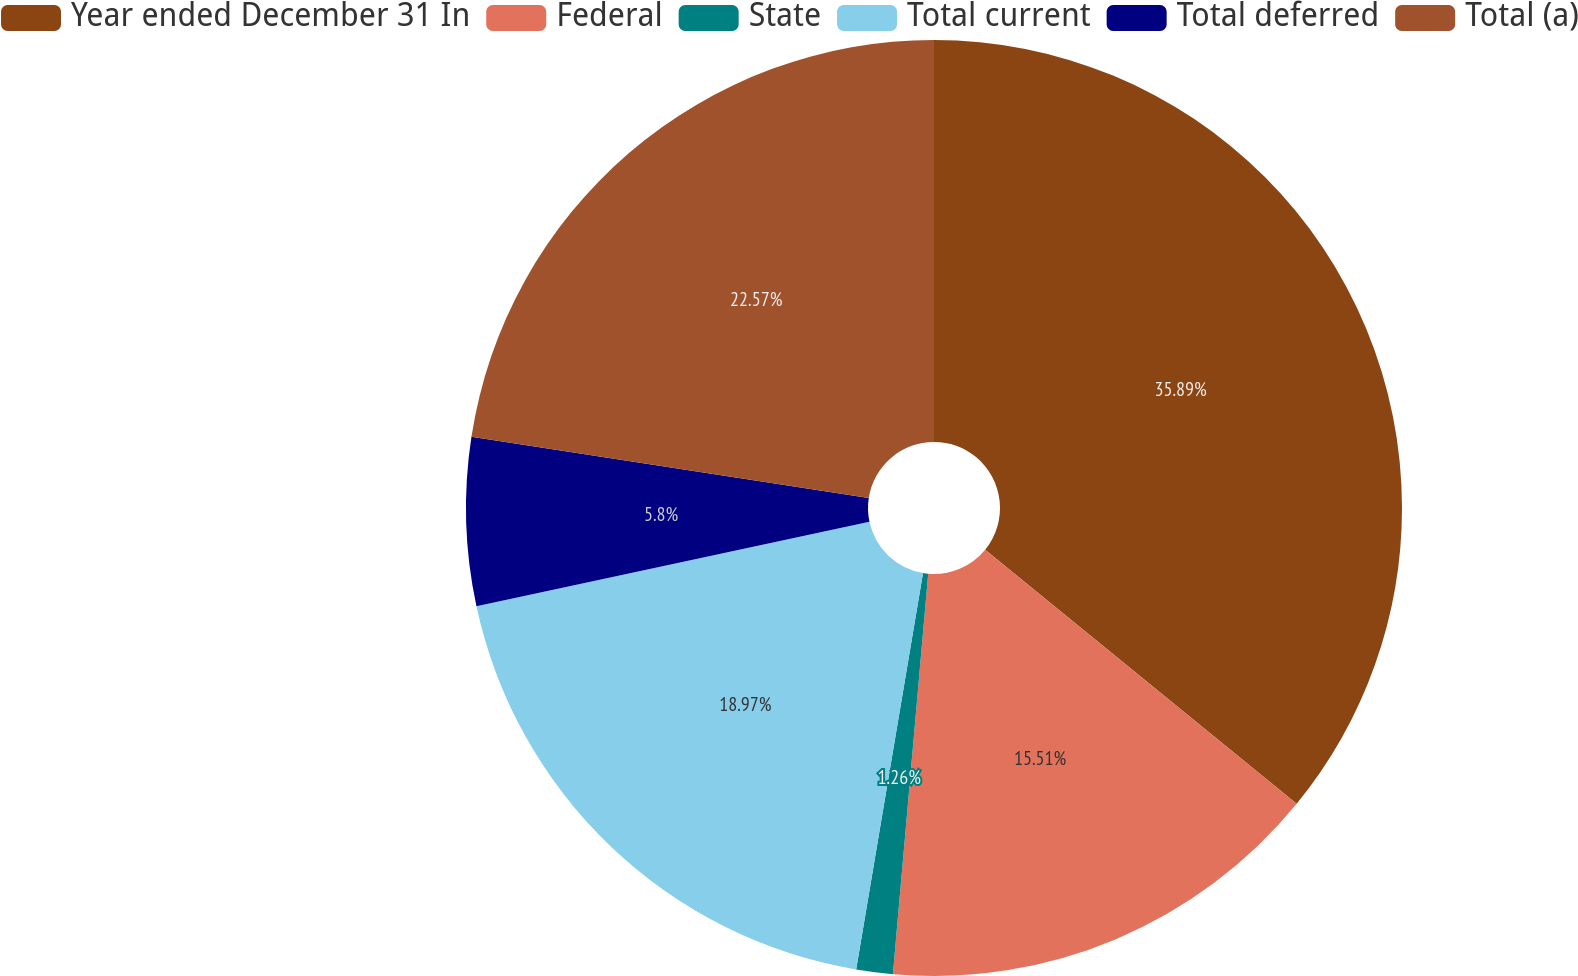Convert chart. <chart><loc_0><loc_0><loc_500><loc_500><pie_chart><fcel>Year ended December 31 In<fcel>Federal<fcel>State<fcel>Total current<fcel>Total deferred<fcel>Total (a)<nl><fcel>35.89%<fcel>15.51%<fcel>1.26%<fcel>18.97%<fcel>5.8%<fcel>22.57%<nl></chart> 